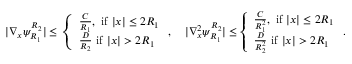Convert formula to latex. <formula><loc_0><loc_0><loc_500><loc_500>\begin{array} { r } { | \nabla _ { x } \psi _ { R _ { 1 } } ^ { R _ { 2 } } | \leq \left \{ \begin{array} { l l } { \frac { C } { R _ { 1 } } , i f | x | \leq 2 R _ { 1 } } \\ { \frac { D } { R _ { 2 } } i f | x | > 2 R _ { 1 } } \end{array} , \quad | \nabla _ { x } ^ { 2 } \psi _ { R _ { 1 } } ^ { R _ { 2 } } | \leq \left \{ \begin{array} { l l } { \frac { C } { R _ { 1 } ^ { 2 } } , i f | x | \leq 2 R _ { 1 } } \\ { \frac { D } { R _ { 2 } ^ { 2 } } i f | x | > 2 R _ { 1 } } \end{array} . } \end{array}</formula> 